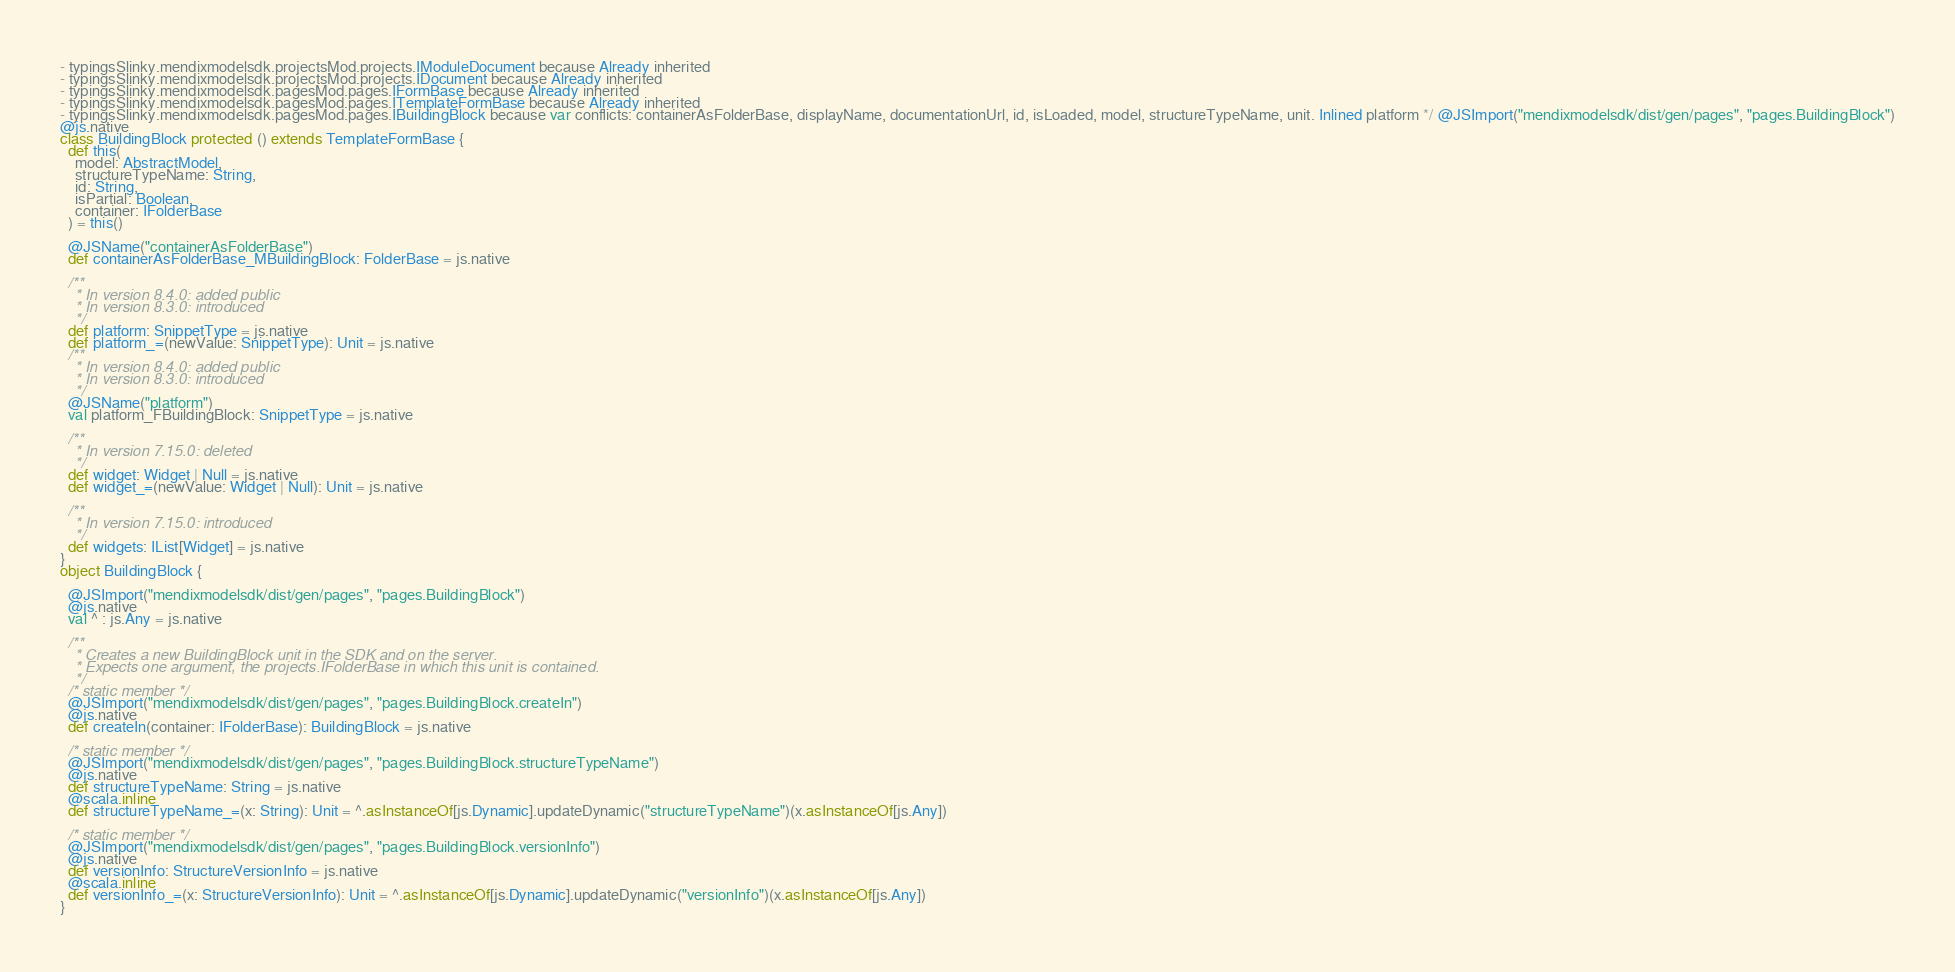<code> <loc_0><loc_0><loc_500><loc_500><_Scala_>- typingsSlinky.mendixmodelsdk.projectsMod.projects.IModuleDocument because Already inherited
- typingsSlinky.mendixmodelsdk.projectsMod.projects.IDocument because Already inherited
- typingsSlinky.mendixmodelsdk.pagesMod.pages.IFormBase because Already inherited
- typingsSlinky.mendixmodelsdk.pagesMod.pages.ITemplateFormBase because Already inherited
- typingsSlinky.mendixmodelsdk.pagesMod.pages.IBuildingBlock because var conflicts: containerAsFolderBase, displayName, documentationUrl, id, isLoaded, model, structureTypeName, unit. Inlined platform */ @JSImport("mendixmodelsdk/dist/gen/pages", "pages.BuildingBlock")
@js.native
class BuildingBlock protected () extends TemplateFormBase {
  def this(
    model: AbstractModel,
    structureTypeName: String,
    id: String,
    isPartial: Boolean,
    container: IFolderBase
  ) = this()
  
  @JSName("containerAsFolderBase")
  def containerAsFolderBase_MBuildingBlock: FolderBase = js.native
  
  /**
    * In version 8.4.0: added public
    * In version 8.3.0: introduced
    */
  def platform: SnippetType = js.native
  def platform_=(newValue: SnippetType): Unit = js.native
  /**
    * In version 8.4.0: added public
    * In version 8.3.0: introduced
    */
  @JSName("platform")
  val platform_FBuildingBlock: SnippetType = js.native
  
  /**
    * In version 7.15.0: deleted
    */
  def widget: Widget | Null = js.native
  def widget_=(newValue: Widget | Null): Unit = js.native
  
  /**
    * In version 7.15.0: introduced
    */
  def widgets: IList[Widget] = js.native
}
object BuildingBlock {
  
  @JSImport("mendixmodelsdk/dist/gen/pages", "pages.BuildingBlock")
  @js.native
  val ^ : js.Any = js.native
  
  /**
    * Creates a new BuildingBlock unit in the SDK and on the server.
    * Expects one argument, the projects.IFolderBase in which this unit is contained.
    */
  /* static member */
  @JSImport("mendixmodelsdk/dist/gen/pages", "pages.BuildingBlock.createIn")
  @js.native
  def createIn(container: IFolderBase): BuildingBlock = js.native
  
  /* static member */
  @JSImport("mendixmodelsdk/dist/gen/pages", "pages.BuildingBlock.structureTypeName")
  @js.native
  def structureTypeName: String = js.native
  @scala.inline
  def structureTypeName_=(x: String): Unit = ^.asInstanceOf[js.Dynamic].updateDynamic("structureTypeName")(x.asInstanceOf[js.Any])
  
  /* static member */
  @JSImport("mendixmodelsdk/dist/gen/pages", "pages.BuildingBlock.versionInfo")
  @js.native
  def versionInfo: StructureVersionInfo = js.native
  @scala.inline
  def versionInfo_=(x: StructureVersionInfo): Unit = ^.asInstanceOf[js.Dynamic].updateDynamic("versionInfo")(x.asInstanceOf[js.Any])
}
</code> 